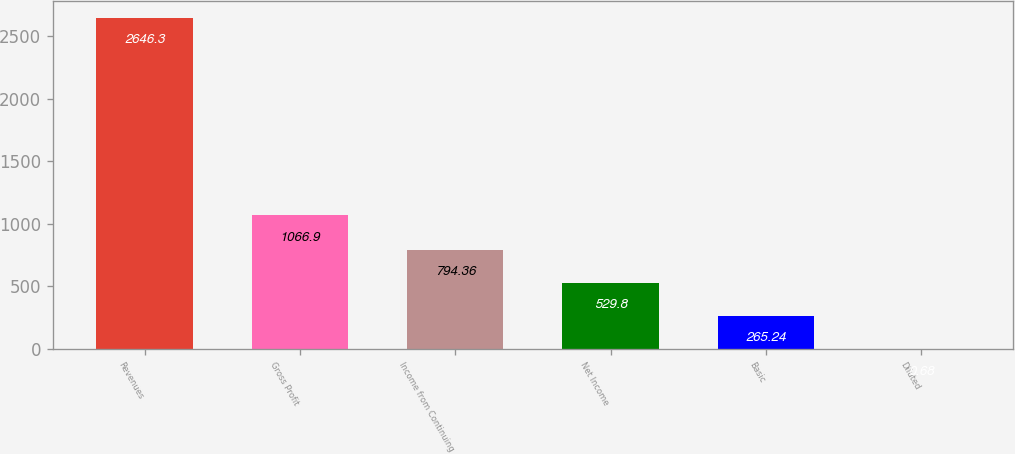Convert chart to OTSL. <chart><loc_0><loc_0><loc_500><loc_500><bar_chart><fcel>Revenues<fcel>Gross Profit<fcel>Income from Continuing<fcel>Net Income<fcel>Basic<fcel>Diluted<nl><fcel>2646.3<fcel>1066.9<fcel>794.36<fcel>529.8<fcel>265.24<fcel>0.68<nl></chart> 